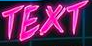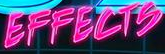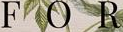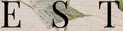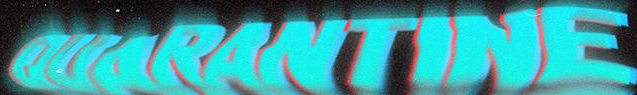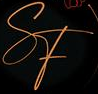What words are shown in these images in order, separated by a semicolon? TEXT; EFFECTS; FOR; EST; OUARANTINE; SF 